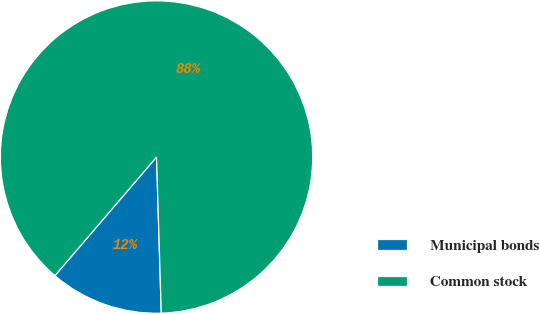<chart> <loc_0><loc_0><loc_500><loc_500><pie_chart><fcel>Municipal bonds<fcel>Common stock<nl><fcel>11.76%<fcel>88.24%<nl></chart> 